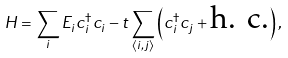Convert formula to latex. <formula><loc_0><loc_0><loc_500><loc_500>H = \sum _ { i } E _ { i } c ^ { \dagger } _ { i } c _ { i } - t \sum _ { \langle i , j \rangle } \left ( c ^ { \dagger } _ { i } c _ { j } + \text {h. c.} \right ) ,</formula> 